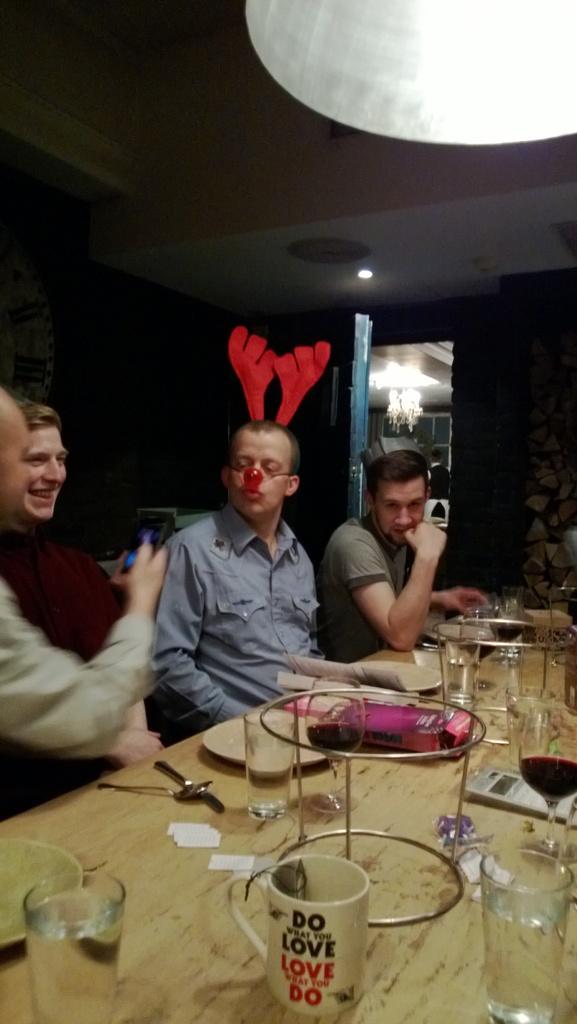Please provide a concise description of this image. It seems to be the image is inside the restaurant. In the image there are four people who are sitting in front of a table. On table we can see a plate,knife,spoon,glass,juice,cloth,water,cup,card,paper. In background we can see a light on top and windows which are closed and on the left side there is a watch which is very big. 